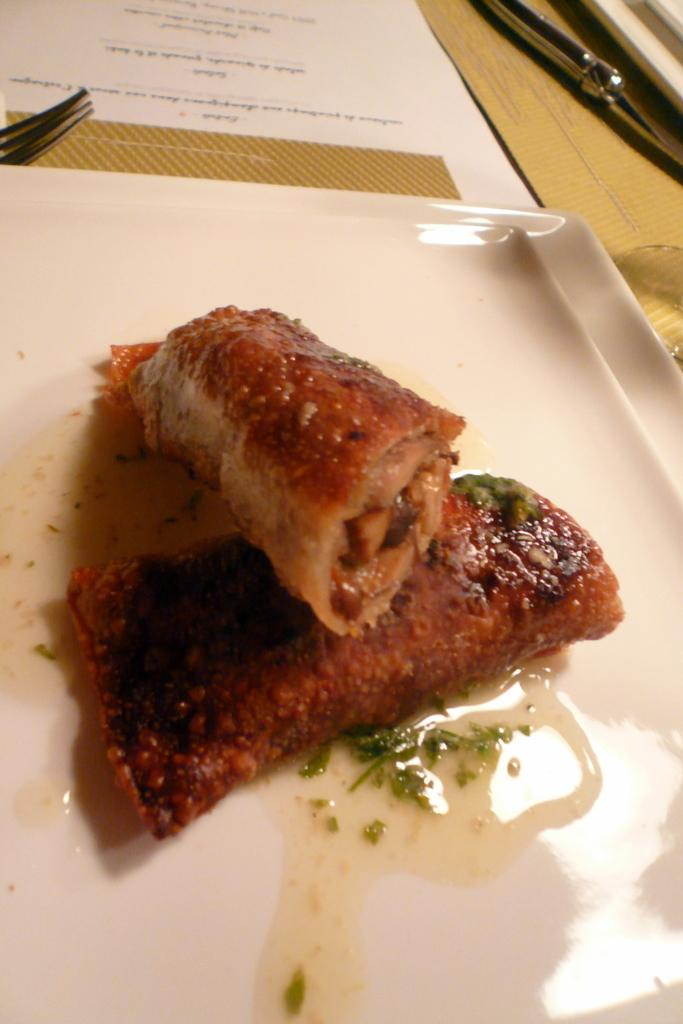What is the color of the tray in the image? The tray in the image is white. What is on the tray in the image? There is food on the tray in the image. What else can be seen in the image besides the tray? There is a white color paper in the image. Are there any cobwebs visible on the tray in the image? No, there are no cobwebs visible on the tray in the image. Can you see anyone's face in the image? No, there are no faces visible in the image. 